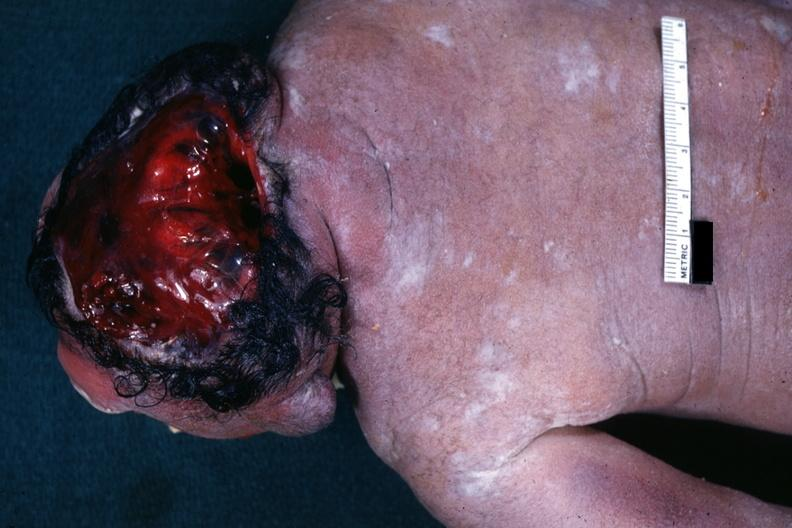what does this image show?
Answer the question using a single word or phrase. View from back typical example 